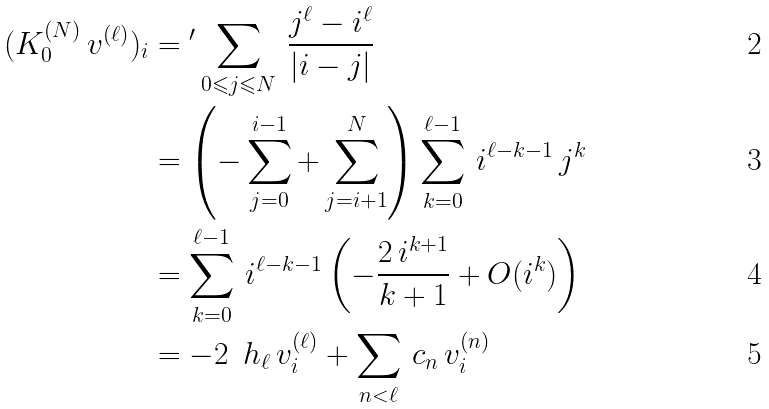Convert formula to latex. <formula><loc_0><loc_0><loc_500><loc_500>( K _ { 0 } ^ { ( N ) } \, v ^ { ( \ell ) } ) _ { i } & = { ^ { \prime } } \sum _ { 0 \leqslant j \leqslant N } \, \frac { j ^ { \ell } - i ^ { \ell } } { | i - j | } \\ & = \left ( - \sum _ { j = 0 } ^ { i - 1 } + \sum _ { j = i + 1 } ^ { N } \right ) \sum _ { k = 0 } ^ { \ell - 1 } \, i ^ { \ell - k - 1 } \, j ^ { k } \\ & = \sum _ { k = 0 } ^ { \ell - 1 } \, i ^ { \ell - k - 1 } \left ( - \frac { 2 \, i ^ { k + 1 } } { k + 1 } + O ( i ^ { k } ) \right ) \\ & = - 2 \, \ h _ { \ell } \, v _ { i } ^ { ( \ell ) } + \sum _ { n < \ell } \, c _ { n } \, v _ { i } ^ { ( n ) }</formula> 